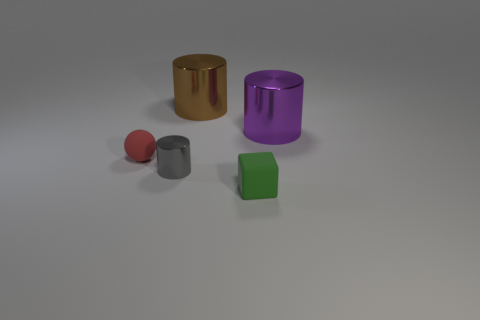The big brown thing has what shape?
Provide a succinct answer. Cylinder. What number of tiny brown cylinders are there?
Provide a short and direct response. 0. There is a metallic object in front of the large object to the right of the green rubber block; what color is it?
Your answer should be very brief. Gray. What is the color of the other thing that is the same size as the purple metal object?
Keep it short and to the point. Brown. Are any large purple matte blocks visible?
Provide a succinct answer. No. What shape is the small rubber thing that is right of the tiny gray cylinder?
Offer a terse response. Cube. What number of metal things are both behind the red ball and in front of the sphere?
Offer a terse response. 0. What number of other objects are the same size as the green matte cube?
Ensure brevity in your answer.  2. There is a big object that is behind the purple metallic cylinder; is it the same shape as the metallic object that is in front of the red object?
Offer a terse response. Yes. How many things are small green rubber blocks or shiny things left of the big purple thing?
Make the answer very short. 3. 